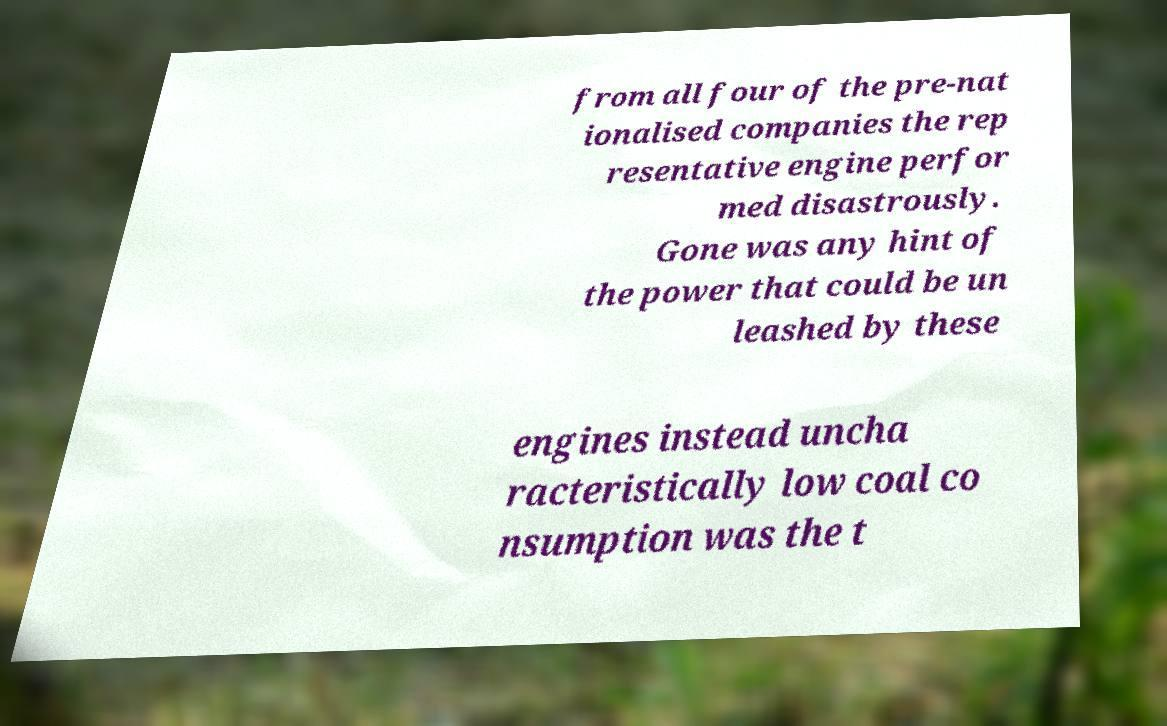Can you accurately transcribe the text from the provided image for me? from all four of the pre-nat ionalised companies the rep resentative engine perfor med disastrously. Gone was any hint of the power that could be un leashed by these engines instead uncha racteristically low coal co nsumption was the t 